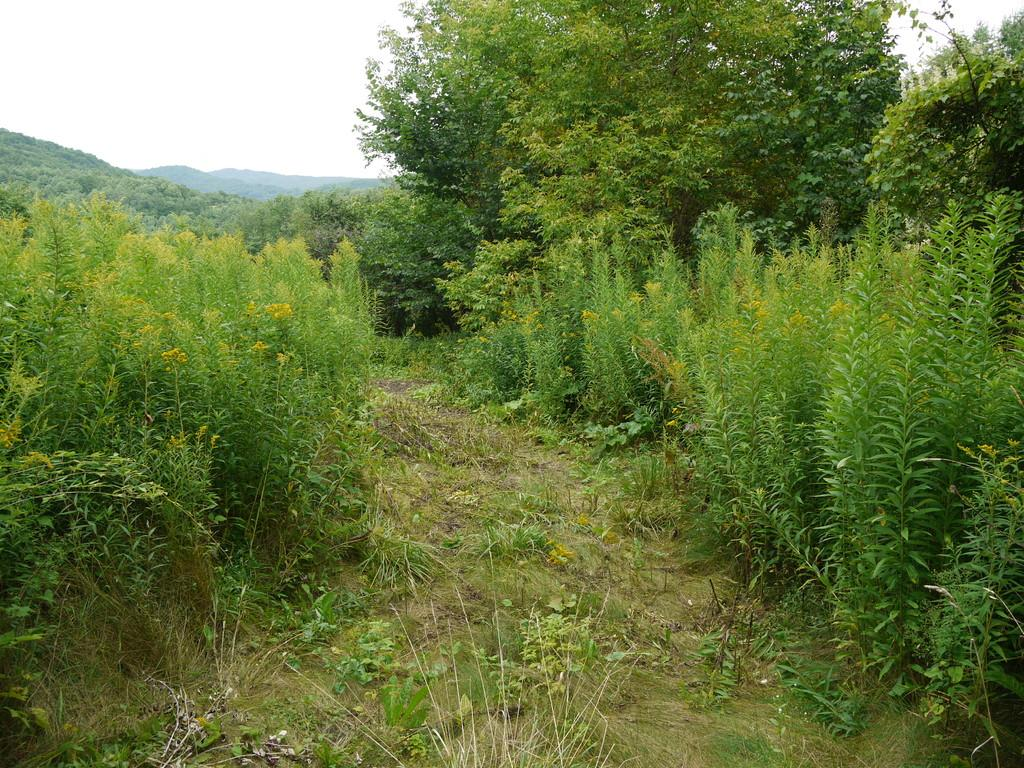What type of vegetation can be seen in the image? There are plants and trees in the image. Can you describe the sky in the image? The sky is cloudy in the image. What type of suit is the wind wearing in the image? There is no wind or suit present in the image. What book is the person reading in the image? There is no person or book visible in the image. 